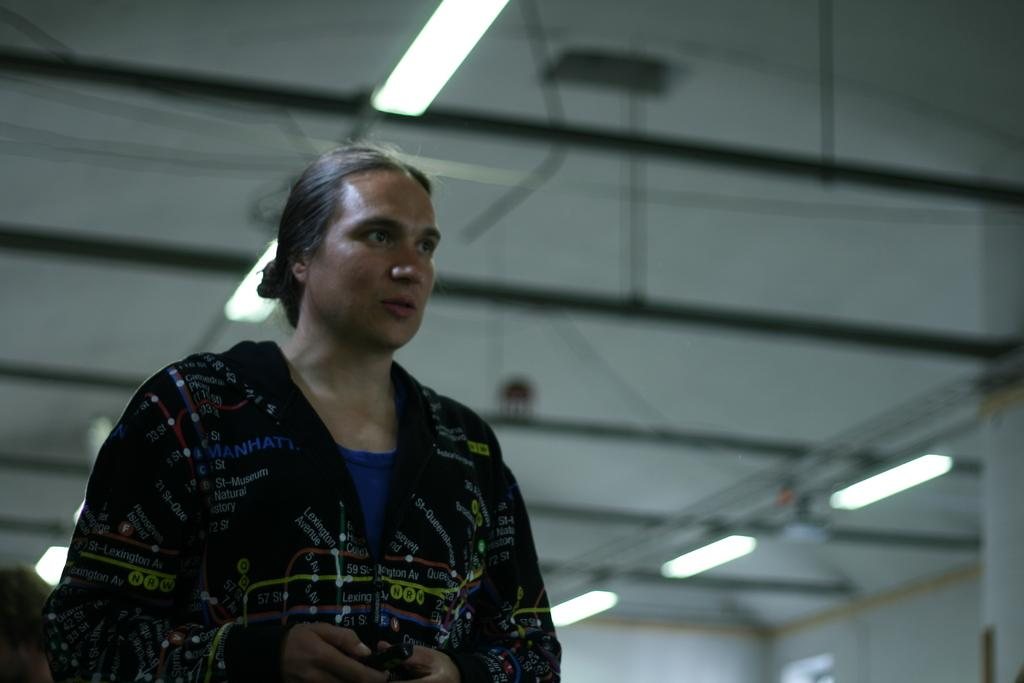What can be seen in the image? There is a person in the image. What is the person holding in their hand? The person is holding an object in their hand. Can you describe the lights in the image? There are lights on top in the image. What type of island can be seen in the background of the image? There is no island visible in the image. 